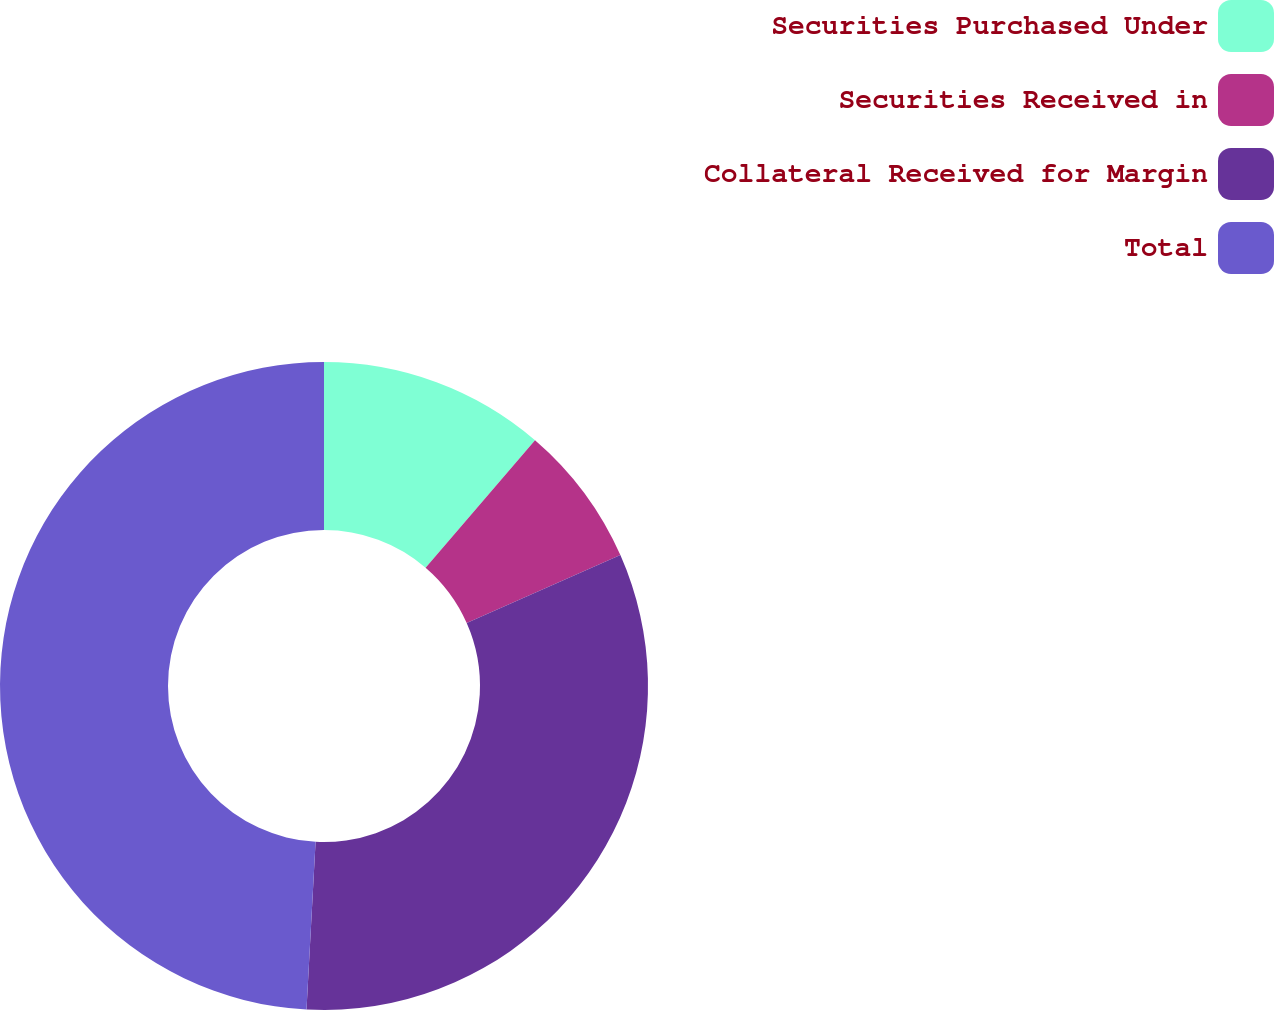<chart> <loc_0><loc_0><loc_500><loc_500><pie_chart><fcel>Securities Purchased Under<fcel>Securities Received in<fcel>Collateral Received for Margin<fcel>Total<nl><fcel>11.29%<fcel>7.09%<fcel>32.48%<fcel>49.14%<nl></chart> 